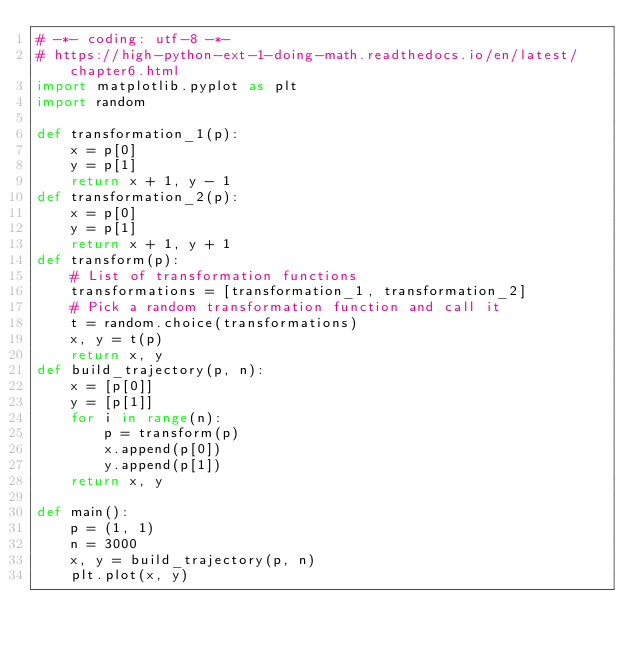<code> <loc_0><loc_0><loc_500><loc_500><_Python_># -*- coding: utf-8 -*-
# https://high-python-ext-1-doing-math.readthedocs.io/en/latest/chapter6.html
import matplotlib.pyplot as plt
import random

def transformation_1(p):
    x = p[0]
    y = p[1]
    return x + 1, y - 1
def transformation_2(p):
    x = p[0]
    y = p[1]
    return x + 1, y + 1
def transform(p):
    # List of transformation functions
    transformations = [transformation_1, transformation_2]
    # Pick a random transformation function and call it
    t = random.choice(transformations)
    x, y = t(p)
    return x, y
def build_trajectory(p, n):
    x = [p[0]]
    y = [p[1]]
    for i in range(n):
        p = transform(p)
        x.append(p[0])
        y.append(p[1])
    return x, y

def main():
    p = (1, 1)
    n = 3000
    x, y = build_trajectory(p, n)
    plt.plot(x, y)
</code> 